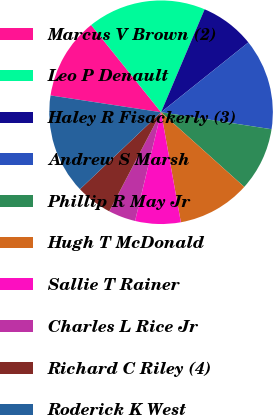Convert chart. <chart><loc_0><loc_0><loc_500><loc_500><pie_chart><fcel>Marcus V Brown (2)<fcel>Leo P Denault<fcel>Haley R Fisackerly (3)<fcel>Andrew S Marsh<fcel>Phillip R May Jr<fcel>Hugh T McDonald<fcel>Sallie T Rainer<fcel>Charles L Rice Jr<fcel>Richard C Riley (4)<fcel>Roderick K West<nl><fcel>11.85%<fcel>17.13%<fcel>7.89%<fcel>13.17%<fcel>9.21%<fcel>10.53%<fcel>6.57%<fcel>3.93%<fcel>5.25%<fcel>14.49%<nl></chart> 